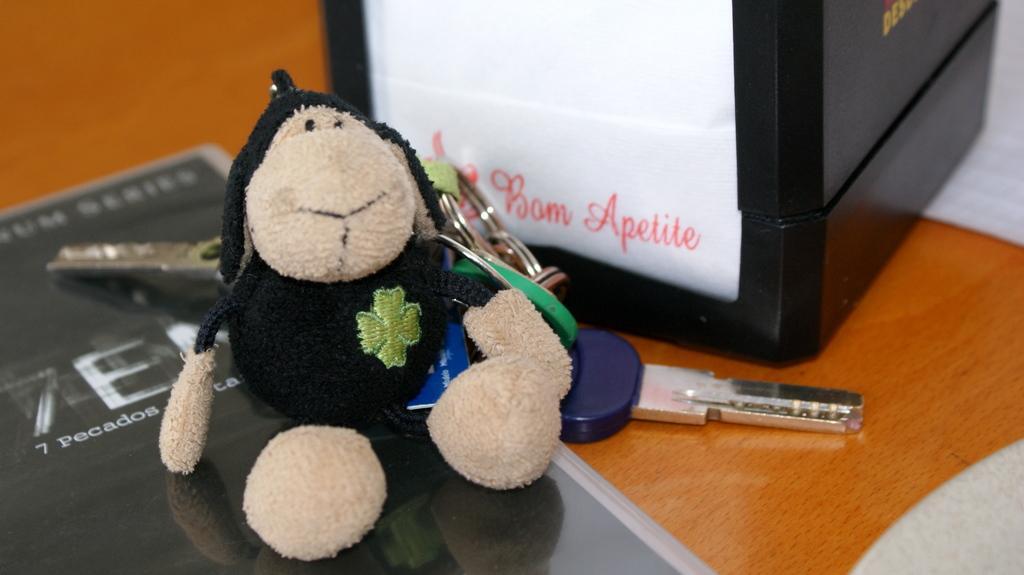Please provide a concise description of this image. In this image I can see a toy, keychains, board and a box on the table. This image is taken may be in a room. 